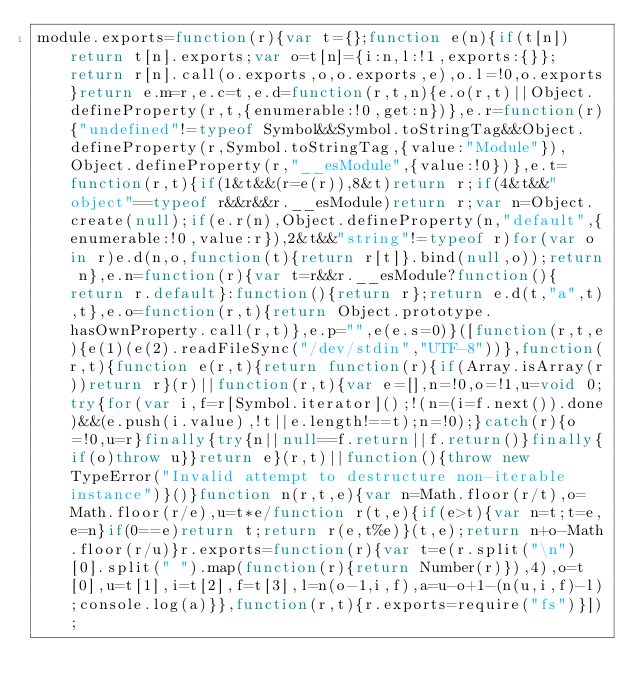<code> <loc_0><loc_0><loc_500><loc_500><_JavaScript_>module.exports=function(r){var t={};function e(n){if(t[n])return t[n].exports;var o=t[n]={i:n,l:!1,exports:{}};return r[n].call(o.exports,o,o.exports,e),o.l=!0,o.exports}return e.m=r,e.c=t,e.d=function(r,t,n){e.o(r,t)||Object.defineProperty(r,t,{enumerable:!0,get:n})},e.r=function(r){"undefined"!=typeof Symbol&&Symbol.toStringTag&&Object.defineProperty(r,Symbol.toStringTag,{value:"Module"}),Object.defineProperty(r,"__esModule",{value:!0})},e.t=function(r,t){if(1&t&&(r=e(r)),8&t)return r;if(4&t&&"object"==typeof r&&r&&r.__esModule)return r;var n=Object.create(null);if(e.r(n),Object.defineProperty(n,"default",{enumerable:!0,value:r}),2&t&&"string"!=typeof r)for(var o in r)e.d(n,o,function(t){return r[t]}.bind(null,o));return n},e.n=function(r){var t=r&&r.__esModule?function(){return r.default}:function(){return r};return e.d(t,"a",t),t},e.o=function(r,t){return Object.prototype.hasOwnProperty.call(r,t)},e.p="",e(e.s=0)}([function(r,t,e){e(1)(e(2).readFileSync("/dev/stdin","UTF-8"))},function(r,t){function e(r,t){return function(r){if(Array.isArray(r))return r}(r)||function(r,t){var e=[],n=!0,o=!1,u=void 0;try{for(var i,f=r[Symbol.iterator]();!(n=(i=f.next()).done)&&(e.push(i.value),!t||e.length!==t);n=!0);}catch(r){o=!0,u=r}finally{try{n||null==f.return||f.return()}finally{if(o)throw u}}return e}(r,t)||function(){throw new TypeError("Invalid attempt to destructure non-iterable instance")}()}function n(r,t,e){var n=Math.floor(r/t),o=Math.floor(r/e),u=t*e/function r(t,e){if(e>t){var n=t;t=e,e=n}if(0==e)return t;return r(e,t%e)}(t,e);return n+o-Math.floor(r/u)}r.exports=function(r){var t=e(r.split("\n")[0].split(" ").map(function(r){return Number(r)}),4),o=t[0],u=t[1],i=t[2],f=t[3],l=n(o-1,i,f),a=u-o+1-(n(u,i,f)-l);console.log(a)}},function(r,t){r.exports=require("fs")}]);</code> 